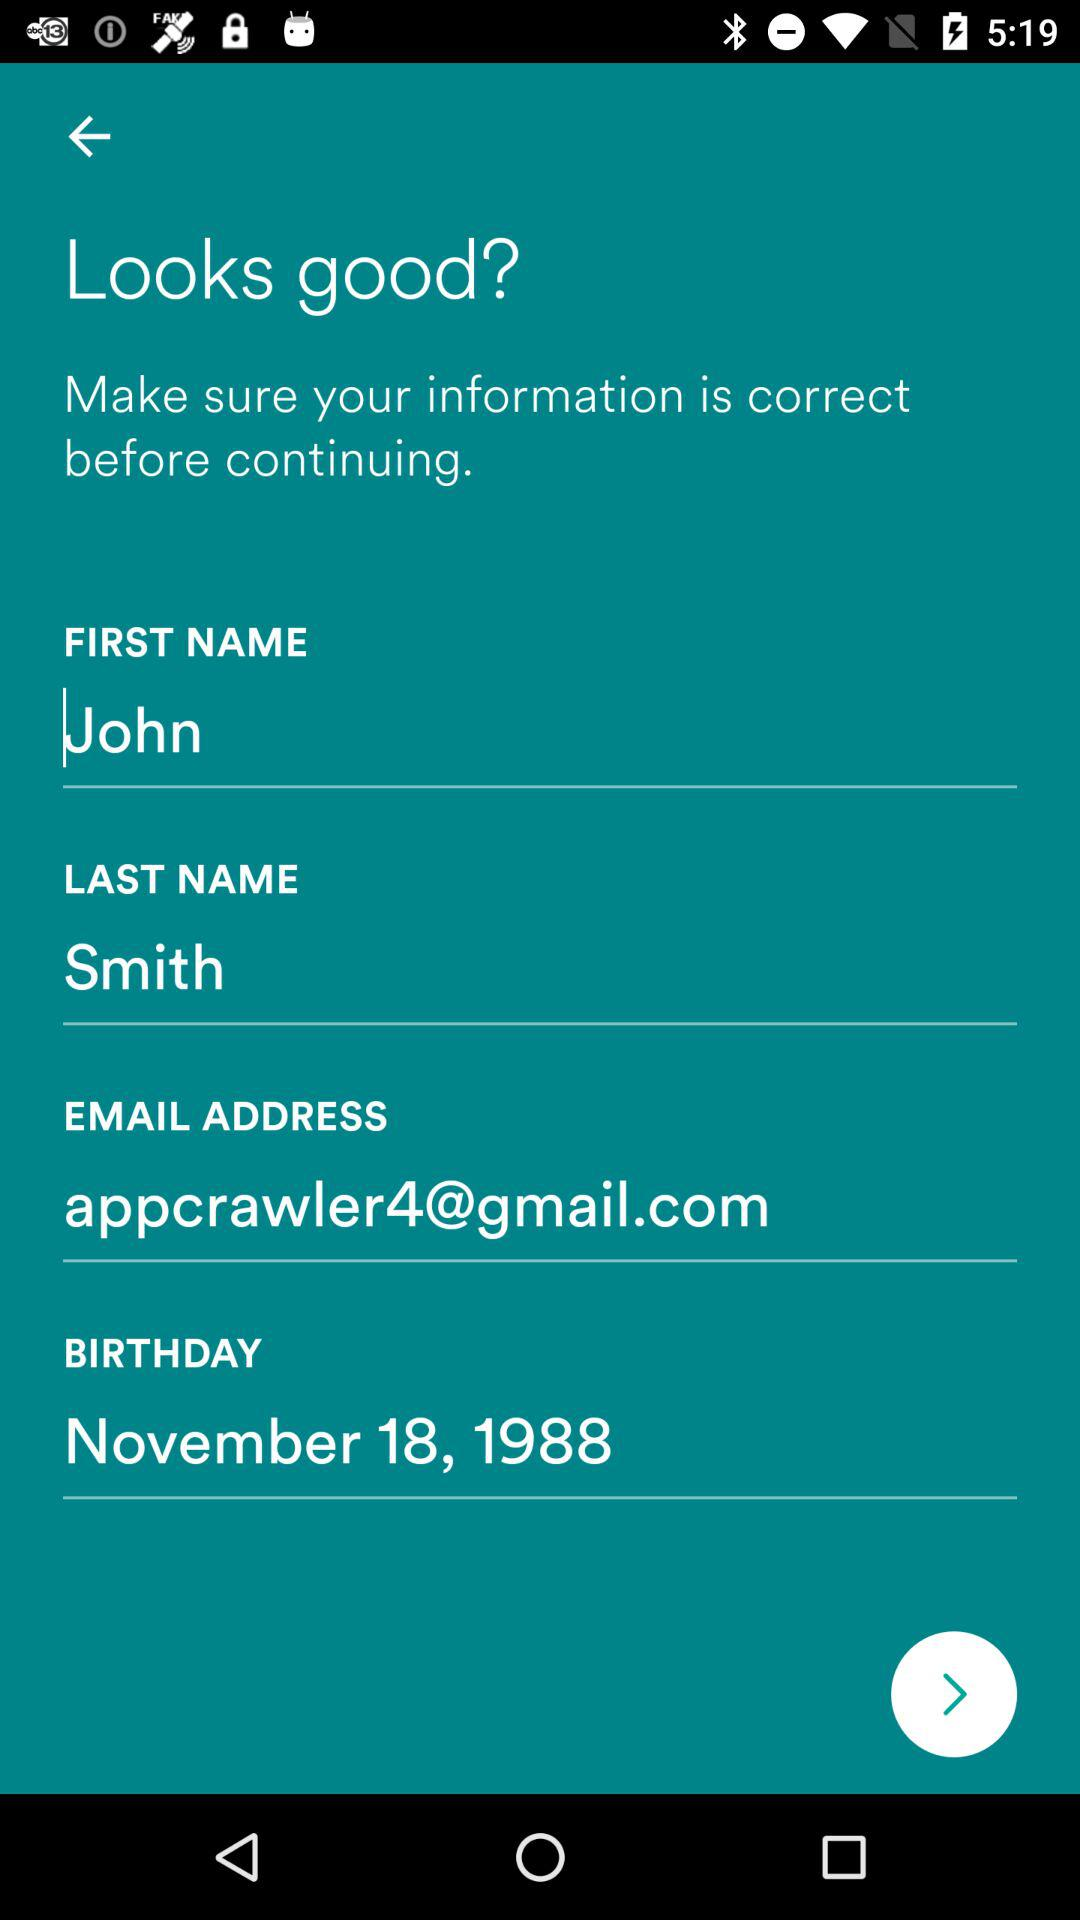What is the email account address? The email account address is appcrawler4@gmail.com. 